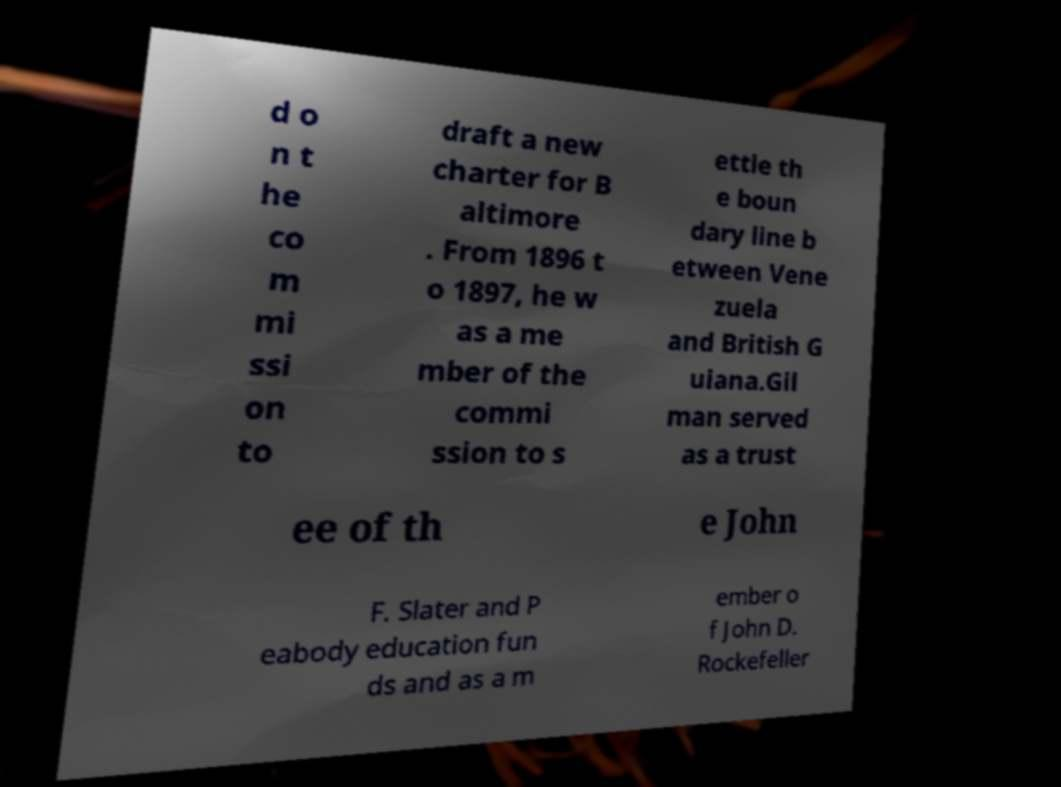Could you assist in decoding the text presented in this image and type it out clearly? d o n t he co m mi ssi on to draft a new charter for B altimore . From 1896 t o 1897, he w as a me mber of the commi ssion to s ettle th e boun dary line b etween Vene zuela and British G uiana.Gil man served as a trust ee of th e John F. Slater and P eabody education fun ds and as a m ember o f John D. Rockefeller 